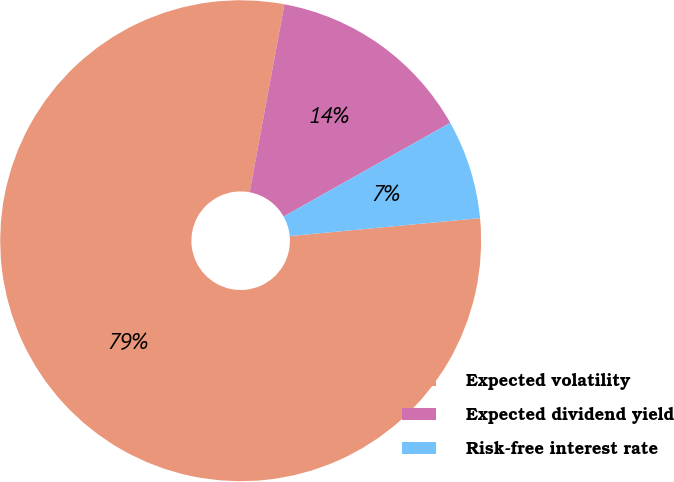<chart> <loc_0><loc_0><loc_500><loc_500><pie_chart><fcel>Expected volatility<fcel>Expected dividend yield<fcel>Risk-free interest rate<nl><fcel>79.41%<fcel>13.93%<fcel>6.66%<nl></chart> 